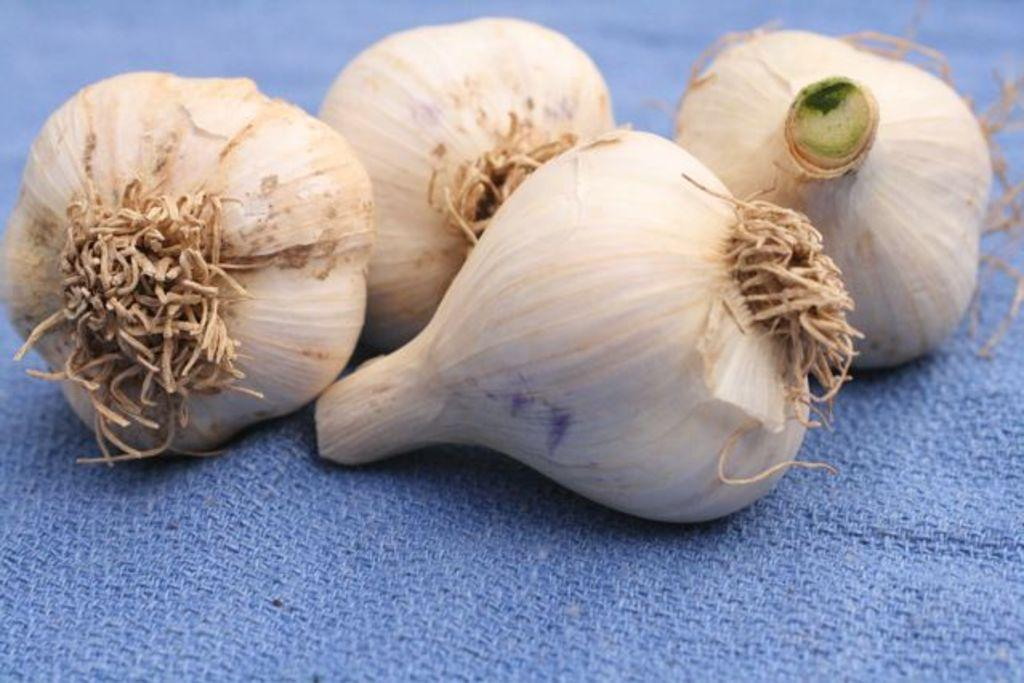How many garlics are present in the image? There are four garlics in the image. What is the color of the cloth on which the garlics are placed? The garlics are on a blue color cloth. What type of jam is being served on the tray in the image? There is no tray or jam present in the image; it features four garlics on a blue color cloth. Can you tell me how many popcorns are visible in the image? There are no popcorns present in the image. 